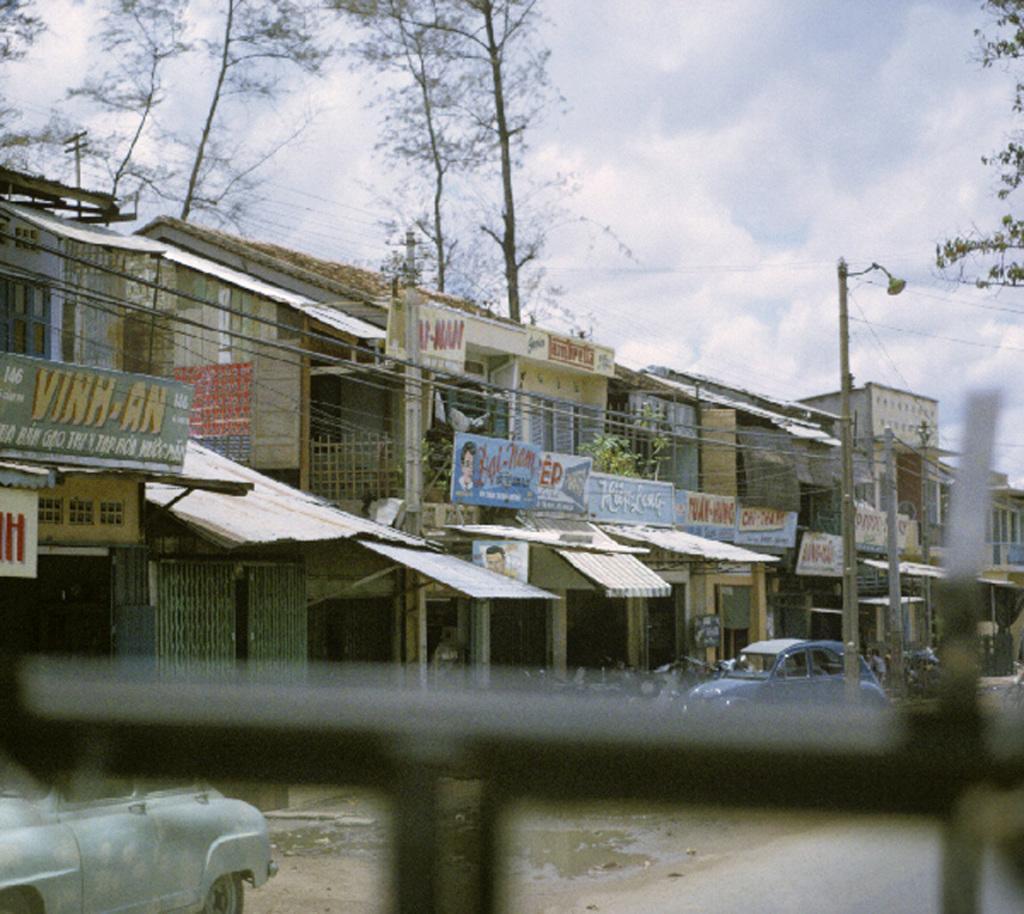How would you summarize this image in a sentence or two? In this image I see number of buildings and I see boards on which there is something written and I see few cars and I see the path and in the background I see the trees, a light pole, wires and the sky which is a bit cloudy and I see that it is blurred over here. 